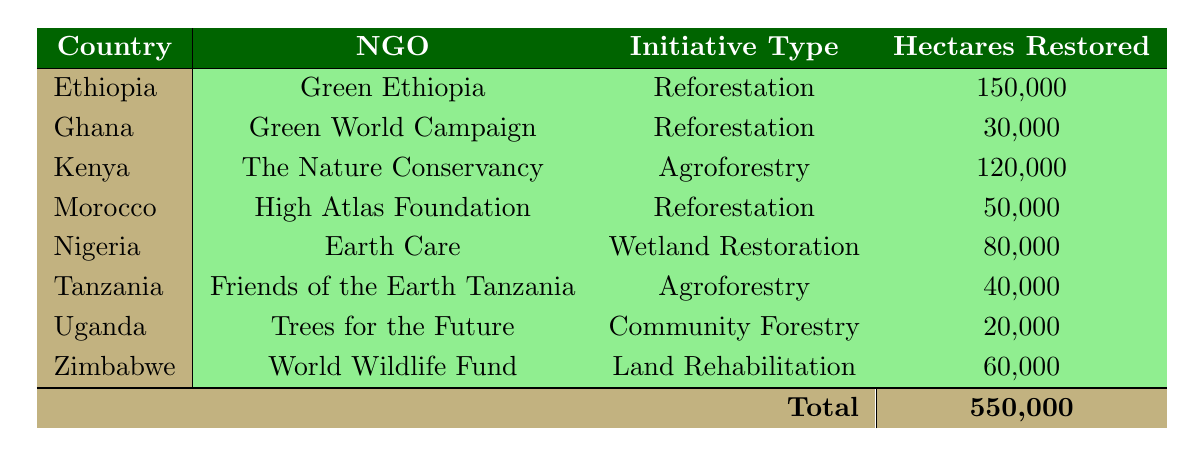What is the total number of hectares restored in Ethiopia? From the table, the only entry for Ethiopia shows 150,000 hectares restored by the NGO Green Ethiopia in 2020. Therefore, the total is simply this value.
Answer: 150,000 Which NGO was responsible for the largest land restoration initiative? By examining the hectares restored for each NGO, Green Ethiopia has restored 150,000 hectares, which is the highest among all listed initiatives. The other NGOs restored fewer hectares.
Answer: Green Ethiopia Is the type of land restoration initiative for Nigeria a form of reforestation? The table specifies that Nigeria's initiative, led by Earth Care, is categorized as wetland restoration, which is not a form of reforestation. Therefore, the answer is no.
Answer: No What is the sum of hectares restored by the NGOs in Kenya and Ghana? The hectares restored by the NGOs in Kenya (The Nature Conservancy) is 120,000 and in Ghana (Green World Campaign) is 30,000. Adding these together gives 120,000 + 30,000 = 150,000 hectares.
Answer: 150,000 Which country has the lowest hectares restored and how many hectares were restored? Upon reviewing the table, Uganda, with Trees for the Future, restored 20,000 hectares, which is the least among all the countries listed.
Answer: Uganda, 20,000 